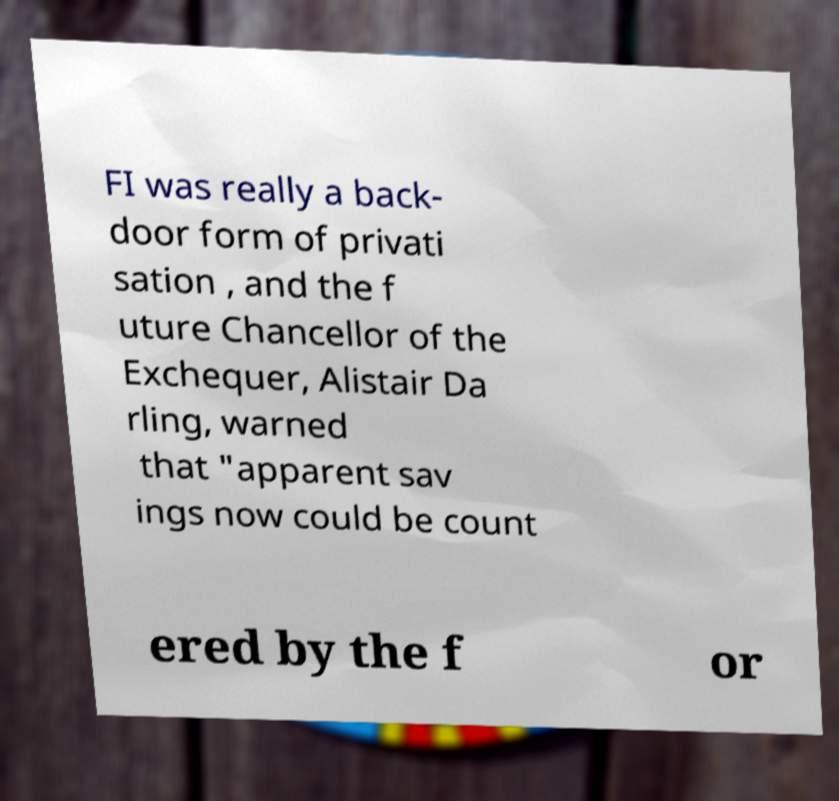Could you extract and type out the text from this image? FI was really a back- door form of privati sation , and the f uture Chancellor of the Exchequer, Alistair Da rling, warned that "apparent sav ings now could be count ered by the f or 